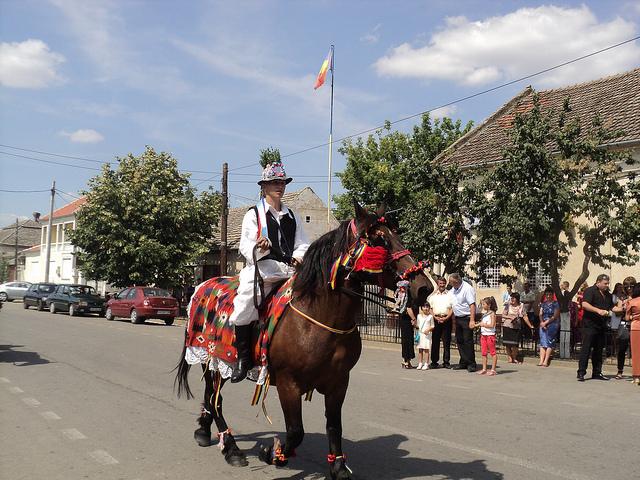What is the horse wearing?
Be succinct. Blanket. Where is the flag?
Quick response, please. Pole. What color is the horse?
Answer briefly. Brown. How many buckles are holding the harness?
Write a very short answer. 2. Is the building in the background a house?
Keep it brief. Yes. Was this pic taken during the day?
Answer briefly. Yes. What color are the two cars?
Short answer required. Red and black. What kind of animal is walking down the street?
Short answer required. Horse. Is the black car in motion?
Answer briefly. No. What animal is in the street?
Keep it brief. Horse. Who are riding the horse?
Short answer required. Man. How many horses are there?
Give a very brief answer. 1. Are some of the people holding hands?
Write a very short answer. Yes. What is the make of the red car?
Give a very brief answer. Toyota. What is the person on the horse holding?
Short answer required. Reins. Is this man working?
Keep it brief. No. What country does the flag in the scene represent?
Keep it brief. France. Is this person wear safety equipment?
Answer briefly. No. What animal is in the parade?
Write a very short answer. Horse. 